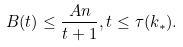Convert formula to latex. <formula><loc_0><loc_0><loc_500><loc_500>B ( t ) \leq \frac { A n } { t + 1 } , t \leq \tau ( k _ { * } ) .</formula> 